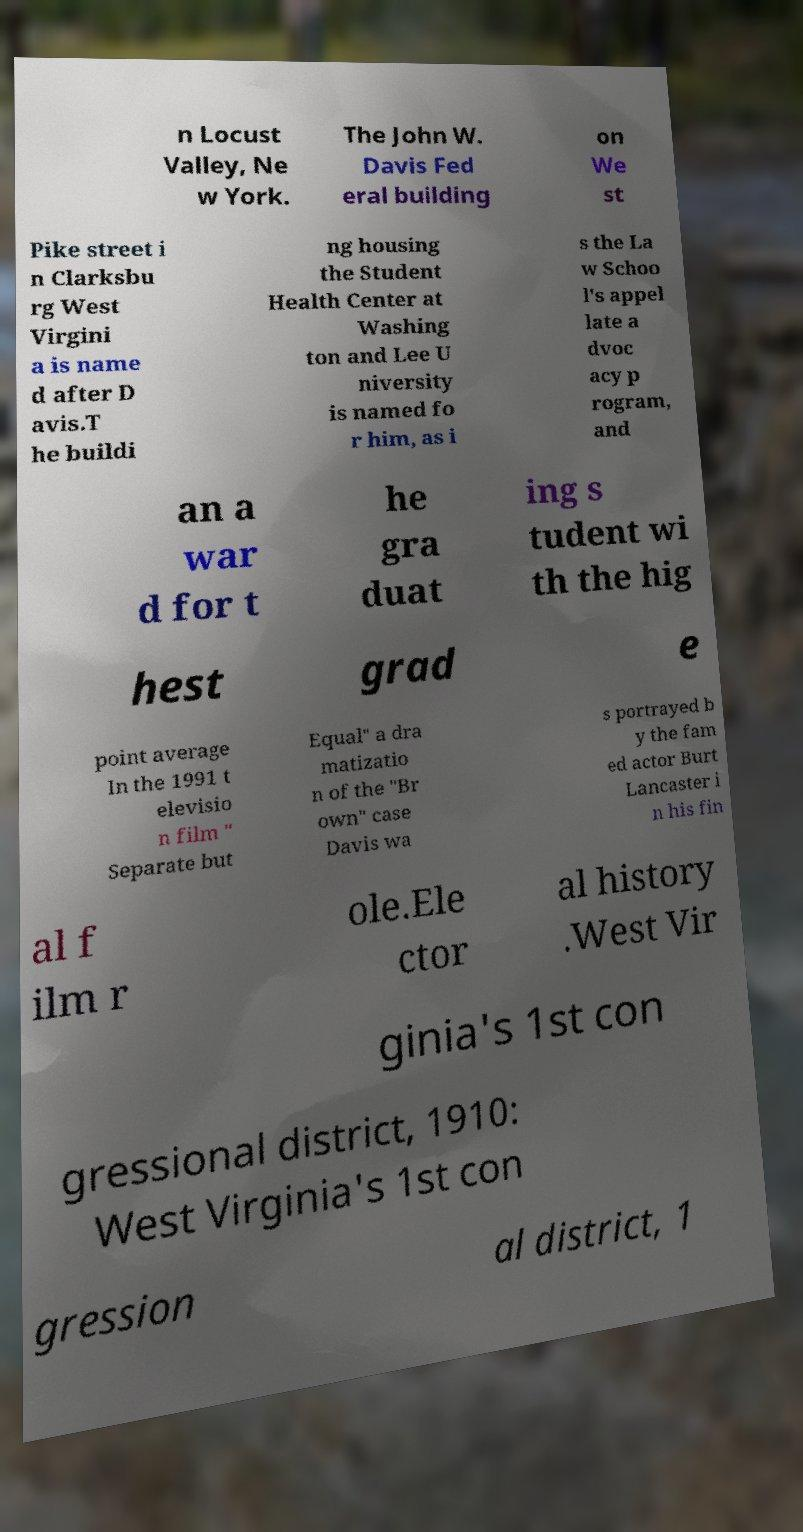For documentation purposes, I need the text within this image transcribed. Could you provide that? n Locust Valley, Ne w York. The John W. Davis Fed eral building on We st Pike street i n Clarksbu rg West Virgini a is name d after D avis.T he buildi ng housing the Student Health Center at Washing ton and Lee U niversity is named fo r him, as i s the La w Schoo l's appel late a dvoc acy p rogram, and an a war d for t he gra duat ing s tudent wi th the hig hest grad e point average In the 1991 t elevisio n film " Separate but Equal" a dra matizatio n of the "Br own" case Davis wa s portrayed b y the fam ed actor Burt Lancaster i n his fin al f ilm r ole.Ele ctor al history .West Vir ginia's 1st con gressional district, 1910: West Virginia's 1st con gression al district, 1 